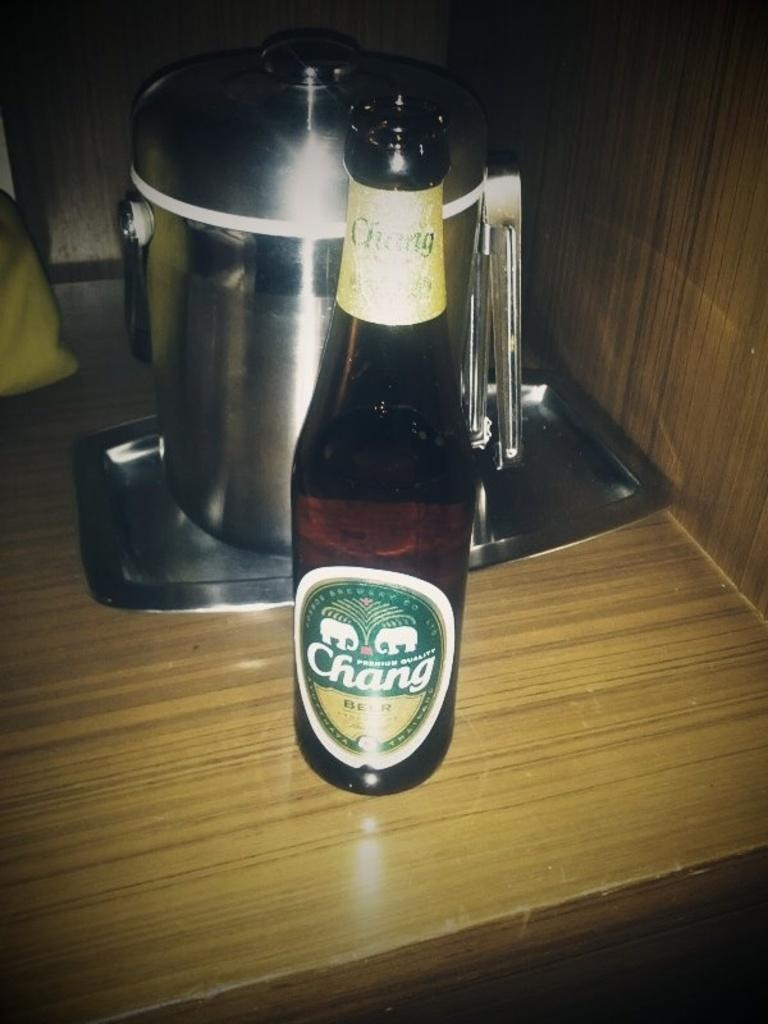What type of furniture is present in the image? There is a table in the image. What color is the table? The table is yellow. What beverage-related item can be seen in the image? There is a wine bottle in the image. What color is the wine bottle? The wine bottle is black. What objects are used for eating or cooking on the table? There are utensils on the table. What color are the utensils? The utensils are ash-colored. What type of treatment is being administered to the brake in the image? There is no brake present in the image, so no treatment is being administered. 